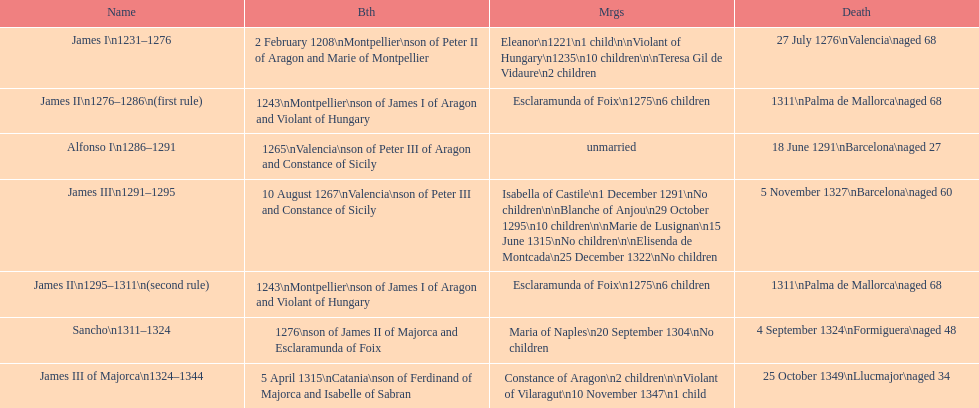Which monarch had the most marriages? James III 1291-1295. I'm looking to parse the entire table for insights. Could you assist me with that? {'header': ['Name', 'Bth', 'Mrgs', 'Death'], 'rows': [['James I\\n1231–1276', '2 February 1208\\nMontpellier\\nson of Peter II of Aragon and Marie of Montpellier', 'Eleanor\\n1221\\n1 child\\n\\nViolant of Hungary\\n1235\\n10 children\\n\\nTeresa Gil de Vidaure\\n2 children', '27 July 1276\\nValencia\\naged 68'], ['James II\\n1276–1286\\n(first rule)', '1243\\nMontpellier\\nson of James I of Aragon and Violant of Hungary', 'Esclaramunda of Foix\\n1275\\n6 children', '1311\\nPalma de Mallorca\\naged 68'], ['Alfonso I\\n1286–1291', '1265\\nValencia\\nson of Peter III of Aragon and Constance of Sicily', 'unmarried', '18 June 1291\\nBarcelona\\naged 27'], ['James III\\n1291–1295', '10 August 1267\\nValencia\\nson of Peter III and Constance of Sicily', 'Isabella of Castile\\n1 December 1291\\nNo children\\n\\nBlanche of Anjou\\n29 October 1295\\n10 children\\n\\nMarie de Lusignan\\n15 June 1315\\nNo children\\n\\nElisenda de Montcada\\n25 December 1322\\nNo children', '5 November 1327\\nBarcelona\\naged 60'], ['James II\\n1295–1311\\n(second rule)', '1243\\nMontpellier\\nson of James I of Aragon and Violant of Hungary', 'Esclaramunda of Foix\\n1275\\n6 children', '1311\\nPalma de Mallorca\\naged 68'], ['Sancho\\n1311–1324', '1276\\nson of James II of Majorca and Esclaramunda of Foix', 'Maria of Naples\\n20 September 1304\\nNo children', '4 September 1324\\nFormiguera\\naged 48'], ['James III of Majorca\\n1324–1344', '5 April 1315\\nCatania\\nson of Ferdinand of Majorca and Isabelle of Sabran', 'Constance of Aragon\\n2 children\\n\\nViolant of Vilaragut\\n10 November 1347\\n1 child', '25 October 1349\\nLlucmajor\\naged 34']]} 